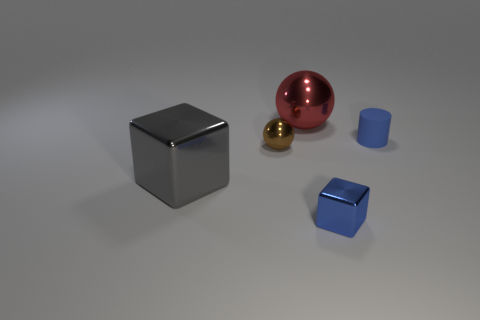Add 4 blue metallic blocks. How many objects exist? 9 Subtract all cylinders. How many objects are left? 4 Subtract 0 purple cubes. How many objects are left? 5 Subtract all small green rubber things. Subtract all tiny rubber objects. How many objects are left? 4 Add 1 tiny cubes. How many tiny cubes are left? 2 Add 4 red rubber balls. How many red rubber balls exist? 4 